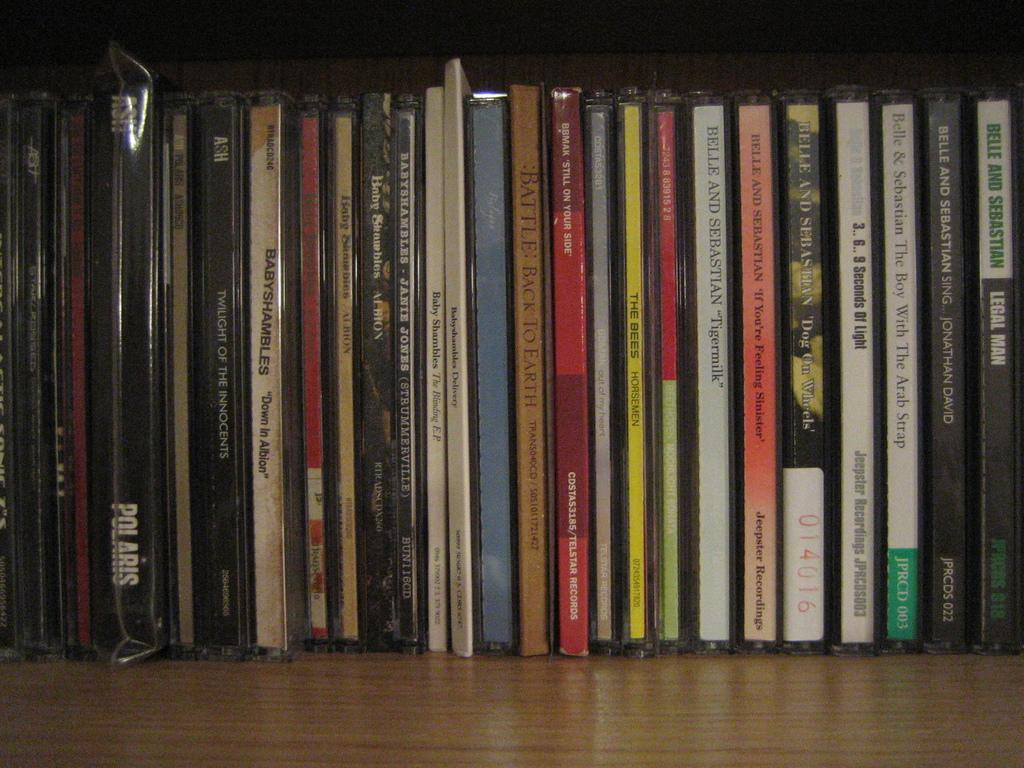<image>
Share a concise interpretation of the image provided. CDs stacked up including Belle and Sebasian and Ash 